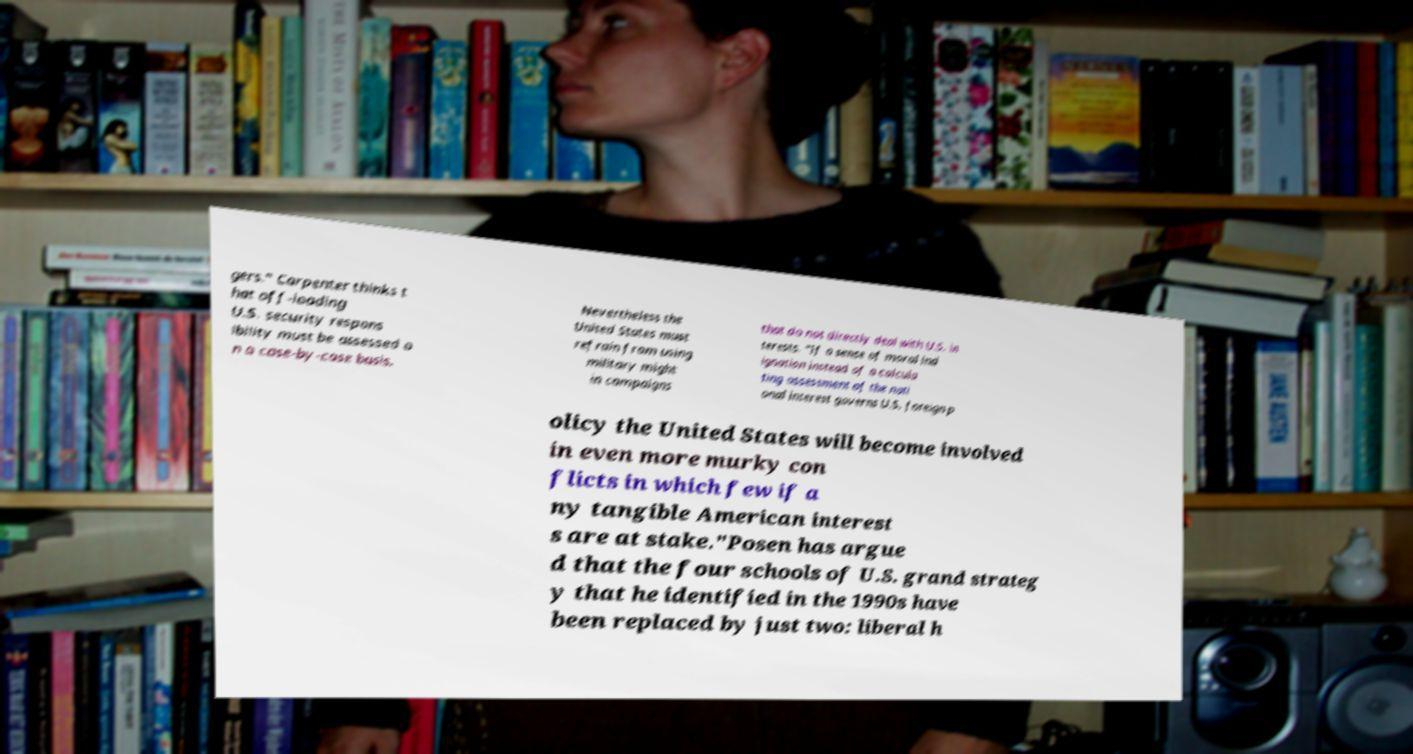There's text embedded in this image that I need extracted. Can you transcribe it verbatim? gers." Carpenter thinks t hat off-loading U.S. security respons ibility must be assessed o n a case-by-case basis. Nevertheless the United States must refrain from using military might in campaigns that do not directly deal with U.S. in terests. "If a sense of moral ind ignation instead of a calcula ting assessment of the nati onal interest governs U.S. foreign p olicy the United States will become involved in even more murky con flicts in which few if a ny tangible American interest s are at stake."Posen has argue d that the four schools of U.S. grand strateg y that he identified in the 1990s have been replaced by just two: liberal h 